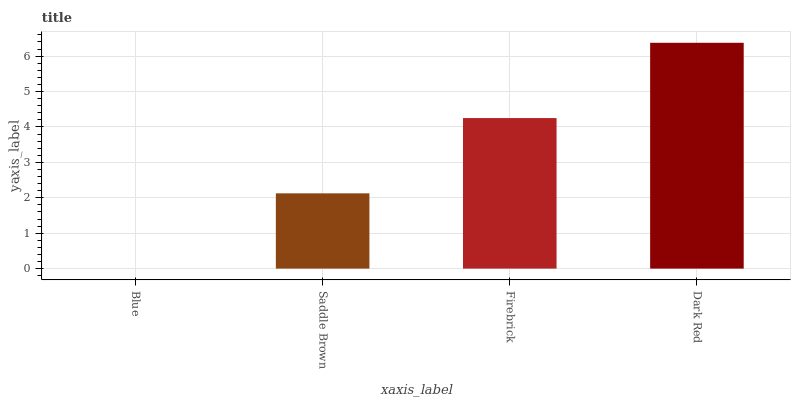Is Blue the minimum?
Answer yes or no. Yes. Is Dark Red the maximum?
Answer yes or no. Yes. Is Saddle Brown the minimum?
Answer yes or no. No. Is Saddle Brown the maximum?
Answer yes or no. No. Is Saddle Brown greater than Blue?
Answer yes or no. Yes. Is Blue less than Saddle Brown?
Answer yes or no. Yes. Is Blue greater than Saddle Brown?
Answer yes or no. No. Is Saddle Brown less than Blue?
Answer yes or no. No. Is Firebrick the high median?
Answer yes or no. Yes. Is Saddle Brown the low median?
Answer yes or no. Yes. Is Blue the high median?
Answer yes or no. No. Is Dark Red the low median?
Answer yes or no. No. 